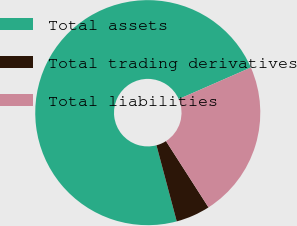Convert chart to OTSL. <chart><loc_0><loc_0><loc_500><loc_500><pie_chart><fcel>Total assets<fcel>Total trading derivatives<fcel>Total liabilities<nl><fcel>72.58%<fcel>4.93%<fcel>22.49%<nl></chart> 